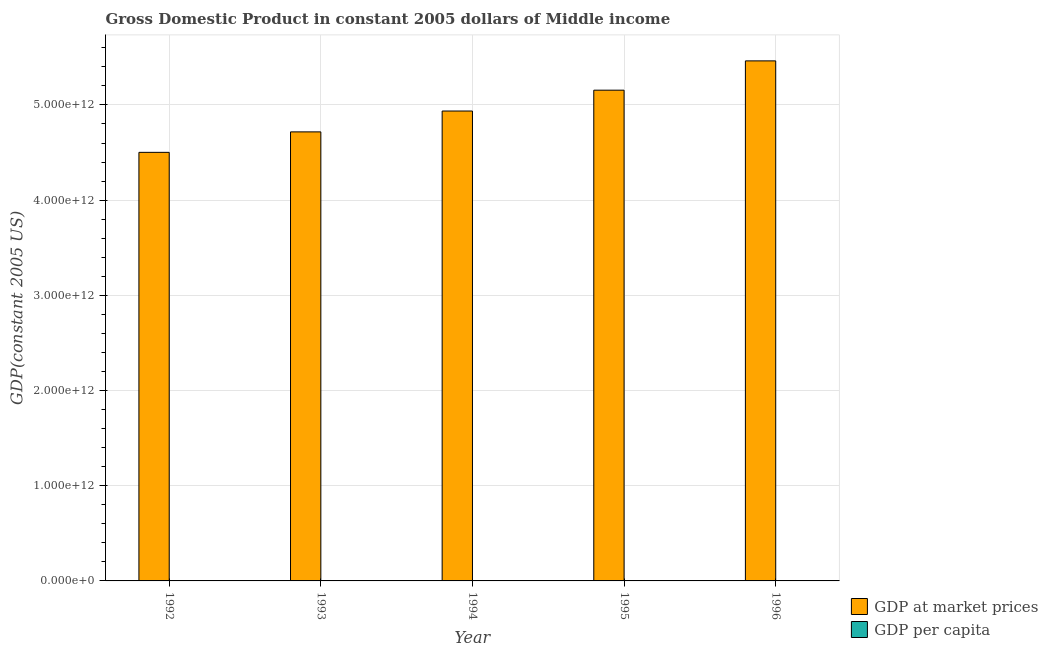How many groups of bars are there?
Offer a terse response. 5. Are the number of bars on each tick of the X-axis equal?
Provide a succinct answer. Yes. What is the label of the 4th group of bars from the left?
Make the answer very short. 1995. In how many cases, is the number of bars for a given year not equal to the number of legend labels?
Give a very brief answer. 0. What is the gdp at market prices in 1992?
Your response must be concise. 4.50e+12. Across all years, what is the maximum gdp at market prices?
Offer a terse response. 5.46e+12. Across all years, what is the minimum gdp at market prices?
Ensure brevity in your answer.  4.50e+12. In which year was the gdp per capita maximum?
Ensure brevity in your answer.  1996. What is the total gdp per capita in the graph?
Your answer should be compact. 6153.06. What is the difference between the gdp at market prices in 1992 and that in 1995?
Give a very brief answer. -6.53e+11. What is the difference between the gdp per capita in 1994 and the gdp at market prices in 1993?
Your answer should be very brief. 35.13. What is the average gdp at market prices per year?
Keep it short and to the point. 4.95e+12. In the year 1994, what is the difference between the gdp per capita and gdp at market prices?
Your answer should be very brief. 0. In how many years, is the gdp per capita greater than 1600000000000 US$?
Your answer should be compact. 0. What is the ratio of the gdp per capita in 1992 to that in 1993?
Make the answer very short. 0.97. Is the gdp at market prices in 1992 less than that in 1995?
Provide a short and direct response. Yes. Is the difference between the gdp per capita in 1992 and 1996 greater than the difference between the gdp at market prices in 1992 and 1996?
Ensure brevity in your answer.  No. What is the difference between the highest and the second highest gdp at market prices?
Provide a short and direct response. 3.08e+11. What is the difference between the highest and the lowest gdp at market prices?
Offer a terse response. 9.61e+11. In how many years, is the gdp per capita greater than the average gdp per capita taken over all years?
Provide a succinct answer. 2. Is the sum of the gdp at market prices in 1993 and 1996 greater than the maximum gdp per capita across all years?
Keep it short and to the point. Yes. What does the 1st bar from the left in 1993 represents?
Offer a very short reply. GDP at market prices. What does the 1st bar from the right in 1996 represents?
Provide a short and direct response. GDP per capita. What is the difference between two consecutive major ticks on the Y-axis?
Ensure brevity in your answer.  1.00e+12. Are the values on the major ticks of Y-axis written in scientific E-notation?
Your answer should be very brief. Yes. Does the graph contain any zero values?
Provide a short and direct response. No. Does the graph contain grids?
Provide a succinct answer. Yes. How are the legend labels stacked?
Provide a succinct answer. Vertical. What is the title of the graph?
Provide a short and direct response. Gross Domestic Product in constant 2005 dollars of Middle income. What is the label or title of the Y-axis?
Keep it short and to the point. GDP(constant 2005 US). What is the GDP(constant 2005 US) in GDP at market prices in 1992?
Your response must be concise. 4.50e+12. What is the GDP(constant 2005 US) in GDP per capita in 1992?
Make the answer very short. 1156.84. What is the GDP(constant 2005 US) in GDP at market prices in 1993?
Ensure brevity in your answer.  4.72e+12. What is the GDP(constant 2005 US) in GDP per capita in 1993?
Provide a short and direct response. 1192. What is the GDP(constant 2005 US) of GDP at market prices in 1994?
Your answer should be compact. 4.94e+12. What is the GDP(constant 2005 US) in GDP per capita in 1994?
Make the answer very short. 1227.14. What is the GDP(constant 2005 US) in GDP at market prices in 1995?
Make the answer very short. 5.15e+12. What is the GDP(constant 2005 US) of GDP per capita in 1995?
Provide a short and direct response. 1261.31. What is the GDP(constant 2005 US) in GDP at market prices in 1996?
Offer a terse response. 5.46e+12. What is the GDP(constant 2005 US) in GDP per capita in 1996?
Your answer should be very brief. 1315.77. Across all years, what is the maximum GDP(constant 2005 US) of GDP at market prices?
Give a very brief answer. 5.46e+12. Across all years, what is the maximum GDP(constant 2005 US) of GDP per capita?
Provide a short and direct response. 1315.77. Across all years, what is the minimum GDP(constant 2005 US) of GDP at market prices?
Make the answer very short. 4.50e+12. Across all years, what is the minimum GDP(constant 2005 US) of GDP per capita?
Your answer should be compact. 1156.84. What is the total GDP(constant 2005 US) in GDP at market prices in the graph?
Provide a short and direct response. 2.48e+13. What is the total GDP(constant 2005 US) of GDP per capita in the graph?
Provide a succinct answer. 6153.06. What is the difference between the GDP(constant 2005 US) in GDP at market prices in 1992 and that in 1993?
Your response must be concise. -2.15e+11. What is the difference between the GDP(constant 2005 US) of GDP per capita in 1992 and that in 1993?
Offer a very short reply. -35.16. What is the difference between the GDP(constant 2005 US) of GDP at market prices in 1992 and that in 1994?
Your response must be concise. -4.34e+11. What is the difference between the GDP(constant 2005 US) in GDP per capita in 1992 and that in 1994?
Keep it short and to the point. -70.3. What is the difference between the GDP(constant 2005 US) in GDP at market prices in 1992 and that in 1995?
Keep it short and to the point. -6.53e+11. What is the difference between the GDP(constant 2005 US) of GDP per capita in 1992 and that in 1995?
Give a very brief answer. -104.47. What is the difference between the GDP(constant 2005 US) in GDP at market prices in 1992 and that in 1996?
Provide a succinct answer. -9.61e+11. What is the difference between the GDP(constant 2005 US) of GDP per capita in 1992 and that in 1996?
Your response must be concise. -158.93. What is the difference between the GDP(constant 2005 US) of GDP at market prices in 1993 and that in 1994?
Your answer should be compact. -2.19e+11. What is the difference between the GDP(constant 2005 US) of GDP per capita in 1993 and that in 1994?
Your response must be concise. -35.13. What is the difference between the GDP(constant 2005 US) in GDP at market prices in 1993 and that in 1995?
Your answer should be very brief. -4.38e+11. What is the difference between the GDP(constant 2005 US) in GDP per capita in 1993 and that in 1995?
Offer a terse response. -69.3. What is the difference between the GDP(constant 2005 US) in GDP at market prices in 1993 and that in 1996?
Offer a very short reply. -7.46e+11. What is the difference between the GDP(constant 2005 US) of GDP per capita in 1993 and that in 1996?
Offer a very short reply. -123.77. What is the difference between the GDP(constant 2005 US) of GDP at market prices in 1994 and that in 1995?
Make the answer very short. -2.19e+11. What is the difference between the GDP(constant 2005 US) of GDP per capita in 1994 and that in 1995?
Offer a terse response. -34.17. What is the difference between the GDP(constant 2005 US) in GDP at market prices in 1994 and that in 1996?
Provide a short and direct response. -5.27e+11. What is the difference between the GDP(constant 2005 US) of GDP per capita in 1994 and that in 1996?
Ensure brevity in your answer.  -88.64. What is the difference between the GDP(constant 2005 US) in GDP at market prices in 1995 and that in 1996?
Offer a very short reply. -3.08e+11. What is the difference between the GDP(constant 2005 US) of GDP per capita in 1995 and that in 1996?
Your answer should be compact. -54.47. What is the difference between the GDP(constant 2005 US) in GDP at market prices in 1992 and the GDP(constant 2005 US) in GDP per capita in 1993?
Provide a succinct answer. 4.50e+12. What is the difference between the GDP(constant 2005 US) in GDP at market prices in 1992 and the GDP(constant 2005 US) in GDP per capita in 1994?
Provide a short and direct response. 4.50e+12. What is the difference between the GDP(constant 2005 US) in GDP at market prices in 1992 and the GDP(constant 2005 US) in GDP per capita in 1995?
Your response must be concise. 4.50e+12. What is the difference between the GDP(constant 2005 US) of GDP at market prices in 1992 and the GDP(constant 2005 US) of GDP per capita in 1996?
Keep it short and to the point. 4.50e+12. What is the difference between the GDP(constant 2005 US) of GDP at market prices in 1993 and the GDP(constant 2005 US) of GDP per capita in 1994?
Ensure brevity in your answer.  4.72e+12. What is the difference between the GDP(constant 2005 US) in GDP at market prices in 1993 and the GDP(constant 2005 US) in GDP per capita in 1995?
Your response must be concise. 4.72e+12. What is the difference between the GDP(constant 2005 US) of GDP at market prices in 1993 and the GDP(constant 2005 US) of GDP per capita in 1996?
Your response must be concise. 4.72e+12. What is the difference between the GDP(constant 2005 US) in GDP at market prices in 1994 and the GDP(constant 2005 US) in GDP per capita in 1995?
Make the answer very short. 4.94e+12. What is the difference between the GDP(constant 2005 US) of GDP at market prices in 1994 and the GDP(constant 2005 US) of GDP per capita in 1996?
Offer a terse response. 4.94e+12. What is the difference between the GDP(constant 2005 US) of GDP at market prices in 1995 and the GDP(constant 2005 US) of GDP per capita in 1996?
Make the answer very short. 5.15e+12. What is the average GDP(constant 2005 US) of GDP at market prices per year?
Provide a succinct answer. 4.95e+12. What is the average GDP(constant 2005 US) in GDP per capita per year?
Offer a terse response. 1230.61. In the year 1992, what is the difference between the GDP(constant 2005 US) in GDP at market prices and GDP(constant 2005 US) in GDP per capita?
Give a very brief answer. 4.50e+12. In the year 1993, what is the difference between the GDP(constant 2005 US) of GDP at market prices and GDP(constant 2005 US) of GDP per capita?
Keep it short and to the point. 4.72e+12. In the year 1994, what is the difference between the GDP(constant 2005 US) in GDP at market prices and GDP(constant 2005 US) in GDP per capita?
Make the answer very short. 4.94e+12. In the year 1995, what is the difference between the GDP(constant 2005 US) of GDP at market prices and GDP(constant 2005 US) of GDP per capita?
Make the answer very short. 5.15e+12. In the year 1996, what is the difference between the GDP(constant 2005 US) of GDP at market prices and GDP(constant 2005 US) of GDP per capita?
Provide a succinct answer. 5.46e+12. What is the ratio of the GDP(constant 2005 US) in GDP at market prices in 1992 to that in 1993?
Your answer should be compact. 0.95. What is the ratio of the GDP(constant 2005 US) of GDP per capita in 1992 to that in 1993?
Make the answer very short. 0.97. What is the ratio of the GDP(constant 2005 US) of GDP at market prices in 1992 to that in 1994?
Keep it short and to the point. 0.91. What is the ratio of the GDP(constant 2005 US) in GDP per capita in 1992 to that in 1994?
Provide a succinct answer. 0.94. What is the ratio of the GDP(constant 2005 US) in GDP at market prices in 1992 to that in 1995?
Offer a very short reply. 0.87. What is the ratio of the GDP(constant 2005 US) of GDP per capita in 1992 to that in 1995?
Make the answer very short. 0.92. What is the ratio of the GDP(constant 2005 US) of GDP at market prices in 1992 to that in 1996?
Ensure brevity in your answer.  0.82. What is the ratio of the GDP(constant 2005 US) in GDP per capita in 1992 to that in 1996?
Give a very brief answer. 0.88. What is the ratio of the GDP(constant 2005 US) in GDP at market prices in 1993 to that in 1994?
Offer a terse response. 0.96. What is the ratio of the GDP(constant 2005 US) of GDP per capita in 1993 to that in 1994?
Make the answer very short. 0.97. What is the ratio of the GDP(constant 2005 US) of GDP at market prices in 1993 to that in 1995?
Make the answer very short. 0.92. What is the ratio of the GDP(constant 2005 US) in GDP per capita in 1993 to that in 1995?
Provide a succinct answer. 0.95. What is the ratio of the GDP(constant 2005 US) in GDP at market prices in 1993 to that in 1996?
Provide a succinct answer. 0.86. What is the ratio of the GDP(constant 2005 US) of GDP per capita in 1993 to that in 1996?
Keep it short and to the point. 0.91. What is the ratio of the GDP(constant 2005 US) of GDP at market prices in 1994 to that in 1995?
Your answer should be very brief. 0.96. What is the ratio of the GDP(constant 2005 US) of GDP per capita in 1994 to that in 1995?
Provide a succinct answer. 0.97. What is the ratio of the GDP(constant 2005 US) of GDP at market prices in 1994 to that in 1996?
Ensure brevity in your answer.  0.9. What is the ratio of the GDP(constant 2005 US) in GDP per capita in 1994 to that in 1996?
Keep it short and to the point. 0.93. What is the ratio of the GDP(constant 2005 US) of GDP at market prices in 1995 to that in 1996?
Your answer should be compact. 0.94. What is the ratio of the GDP(constant 2005 US) of GDP per capita in 1995 to that in 1996?
Your response must be concise. 0.96. What is the difference between the highest and the second highest GDP(constant 2005 US) in GDP at market prices?
Provide a succinct answer. 3.08e+11. What is the difference between the highest and the second highest GDP(constant 2005 US) of GDP per capita?
Your answer should be compact. 54.47. What is the difference between the highest and the lowest GDP(constant 2005 US) in GDP at market prices?
Ensure brevity in your answer.  9.61e+11. What is the difference between the highest and the lowest GDP(constant 2005 US) in GDP per capita?
Make the answer very short. 158.93. 